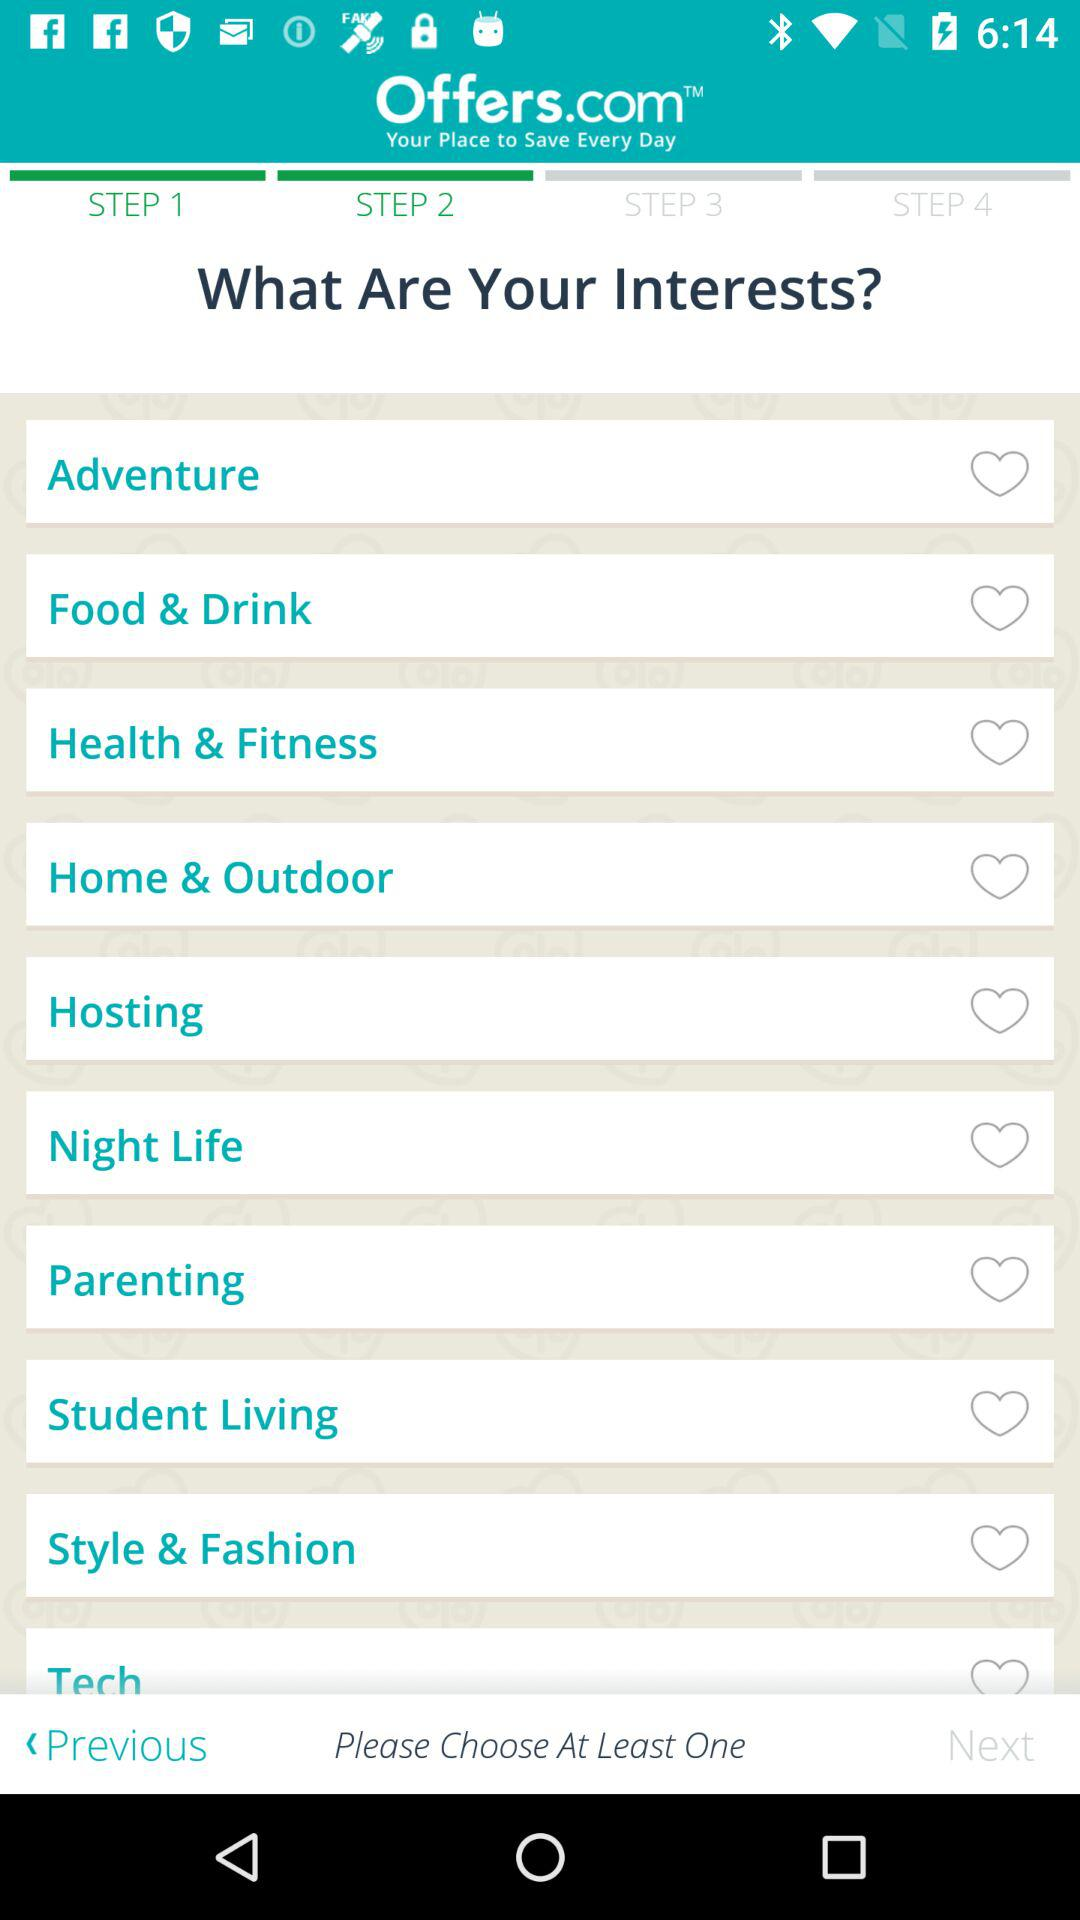What are the available interest options? The available interest options are "Adventure", "Food & Drink", "Health & Fitness", "Home & Outdoor", "Hosting", "Night Life", "Parenting", "Student Living", "Style & Fashion" and "Tech". 